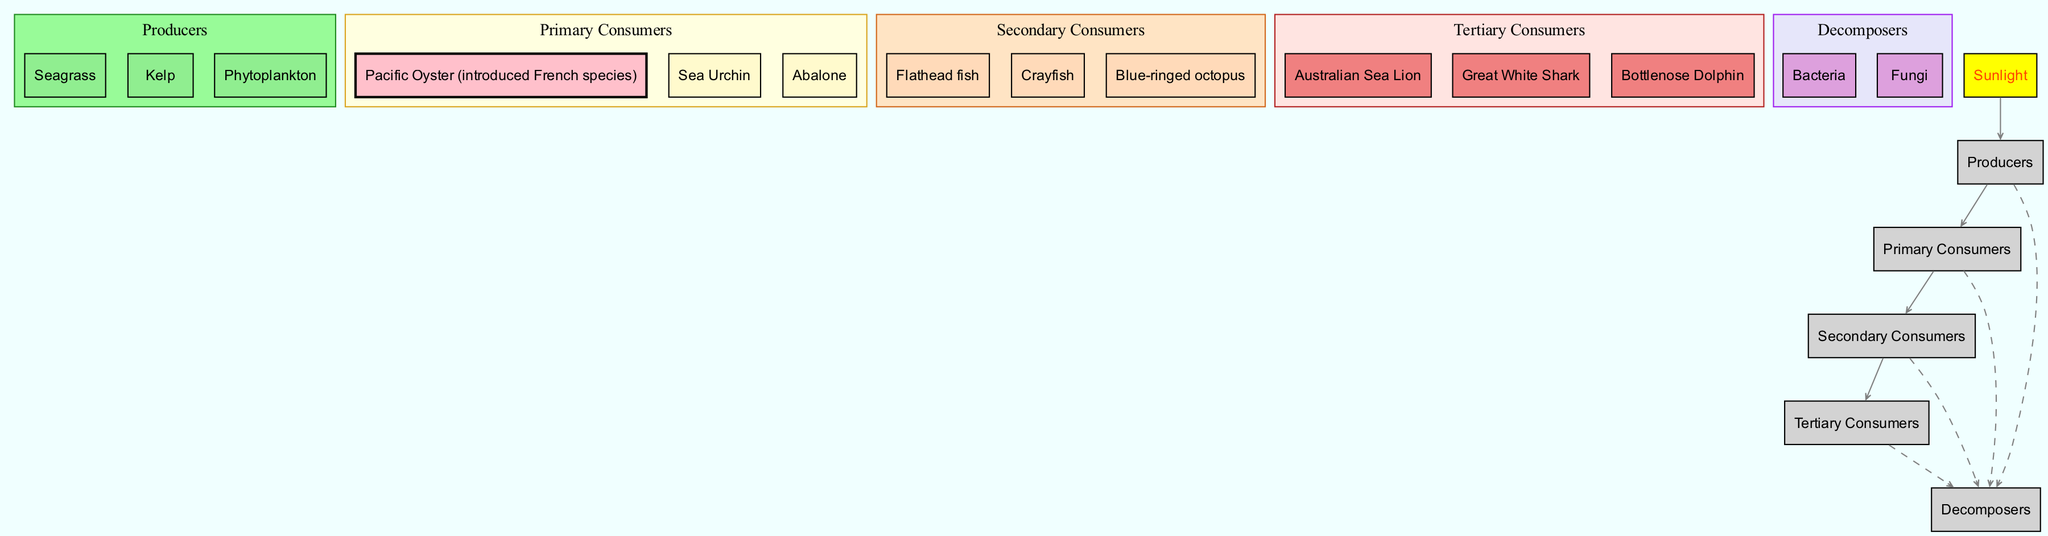What are the producers in the food chain? The producers listed in the diagram include three key species: Seagrass, Kelp, and Phytoplankton, which are the foundation of the food chain.
Answer: Seagrass, Kelp, Phytoplankton How many primary consumers are present? In the diagram, there are three primary consumers: Pacific Oyster, Sea Urchin, and Abalone. Therefore, the total count of primary consumers is three.
Answer: 3 Which species is an introduced French species among the primary consumers? The diagram specifically highlights the Pacific Oyster as the introduced French species within the group of primary consumers.
Answer: Pacific Oyster What directly follows the primary consumers in the food chain? The primary consumers are directly linked to the secondary consumers in the food chain, establishing them as the next level in the diagram.
Answer: Secondary Consumers How many tertiary consumers are listed? The food chain diagram shows a total of three tertiary consumers: Australian Sea Lion, Great White Shark, and Bottlenose Dolphin, indicating the apex predators of the ecosystem.
Answer: 3 What connects the producers to the primary consumers? In the flow of the food chain, the connection from producers to primary consumers is established through arrows that indicate the consumption relationship or energy transfer.
Answer: Producers -> Primary Consumers How do all the levels of the food chain relate to decomposers? The diagram specifies that all levels connect to decomposers through dashed lines, indicating that decomposers play a role in breaking down organisms from every trophic level after they die.
Answer: All levels -> Decomposers Which primary consumer is associated with a different color in the diagram? In the diagram, the Pacific Oyster is highlighted in pink, indicating it as an introduced French species, contrasting with the yellow for other primary consumers.
Answer: Pacific Oyster What is the role of sunlight in the food chain? The role of sunlight is to provide energy for the producers, which is illustrated in the diagram as connecting directly to the producers at the base of the food chain.
Answer: Sunlight -> Producers 